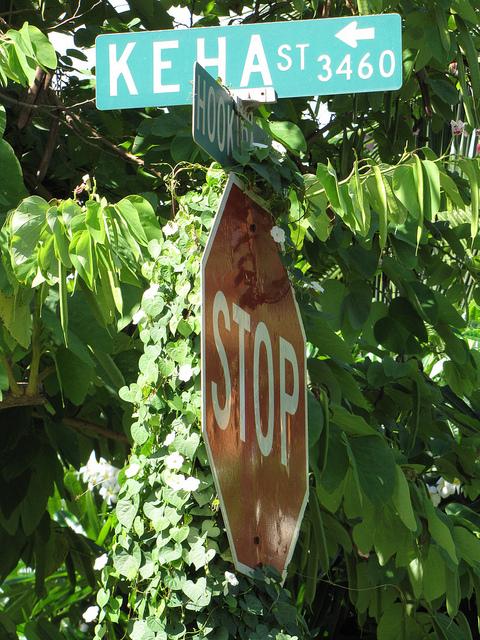What is written on the red sign?
Short answer required. Stop. What is the name on the top street sign?
Short answer required. Ke ha. What color is the writing on the stop sign?
Keep it brief. White. 